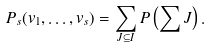Convert formula to latex. <formula><loc_0><loc_0><loc_500><loc_500>P _ { s } ( v _ { 1 } , \dots , v _ { s } ) = \sum _ { J \subseteq I } P \left ( \sum J \right ) .</formula> 